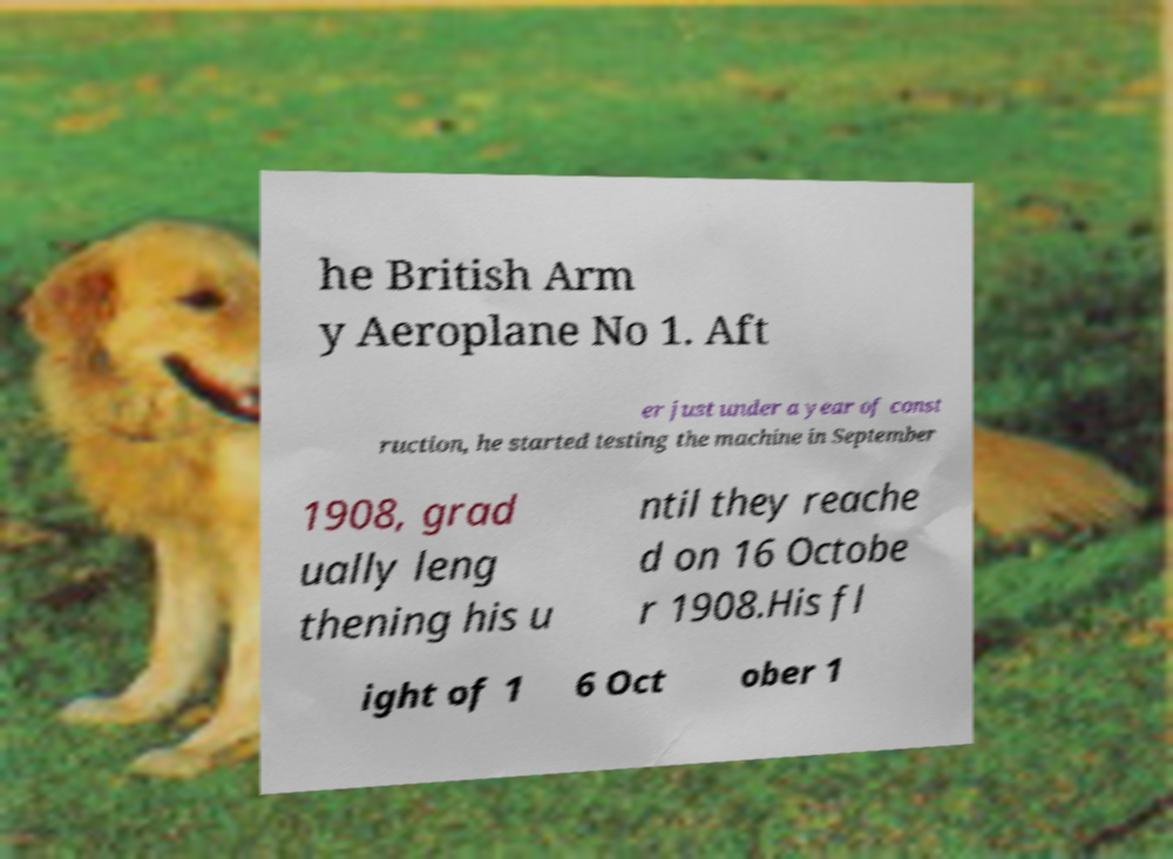There's text embedded in this image that I need extracted. Can you transcribe it verbatim? he British Arm y Aeroplane No 1. Aft er just under a year of const ruction, he started testing the machine in September 1908, grad ually leng thening his u ntil they reache d on 16 Octobe r 1908.His fl ight of 1 6 Oct ober 1 